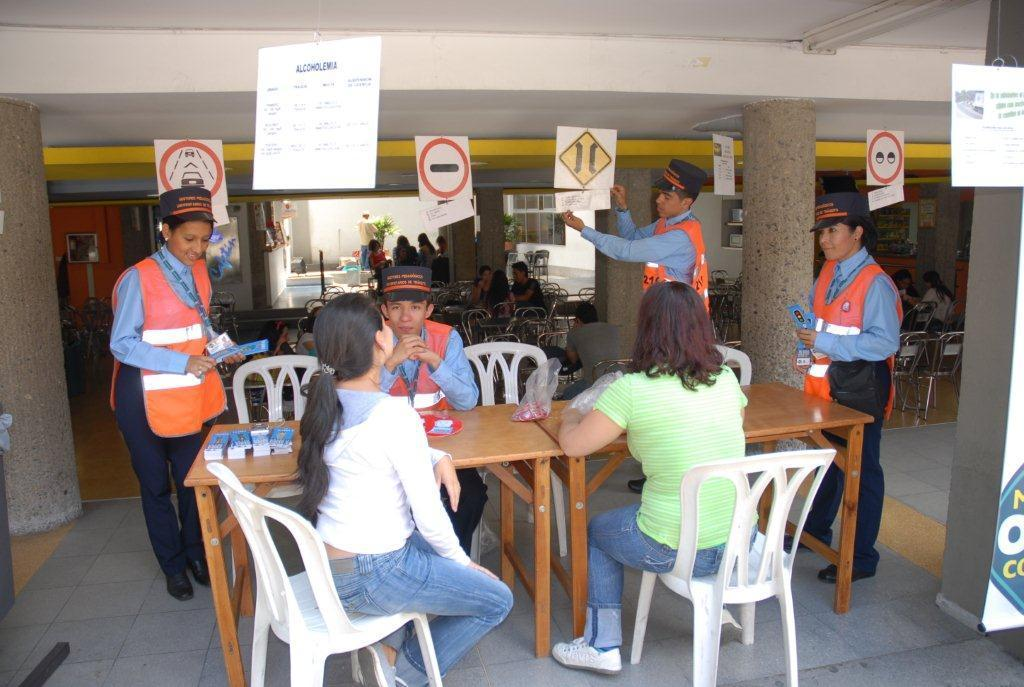How many people are sitting in the image? There is one man and two women sitting in the image. What are the people in the image doing? The man and women are sitting. Can you describe the people standing in the background? There are three persons standing in the background. What objects can be seen in the image besides the people? There is a board and a glass in the image. What type of locket is the man wearing in the image? There is no locket visible on the man in the image. What kind of butter is being used by the women in the image? There is no butter present in the image. 